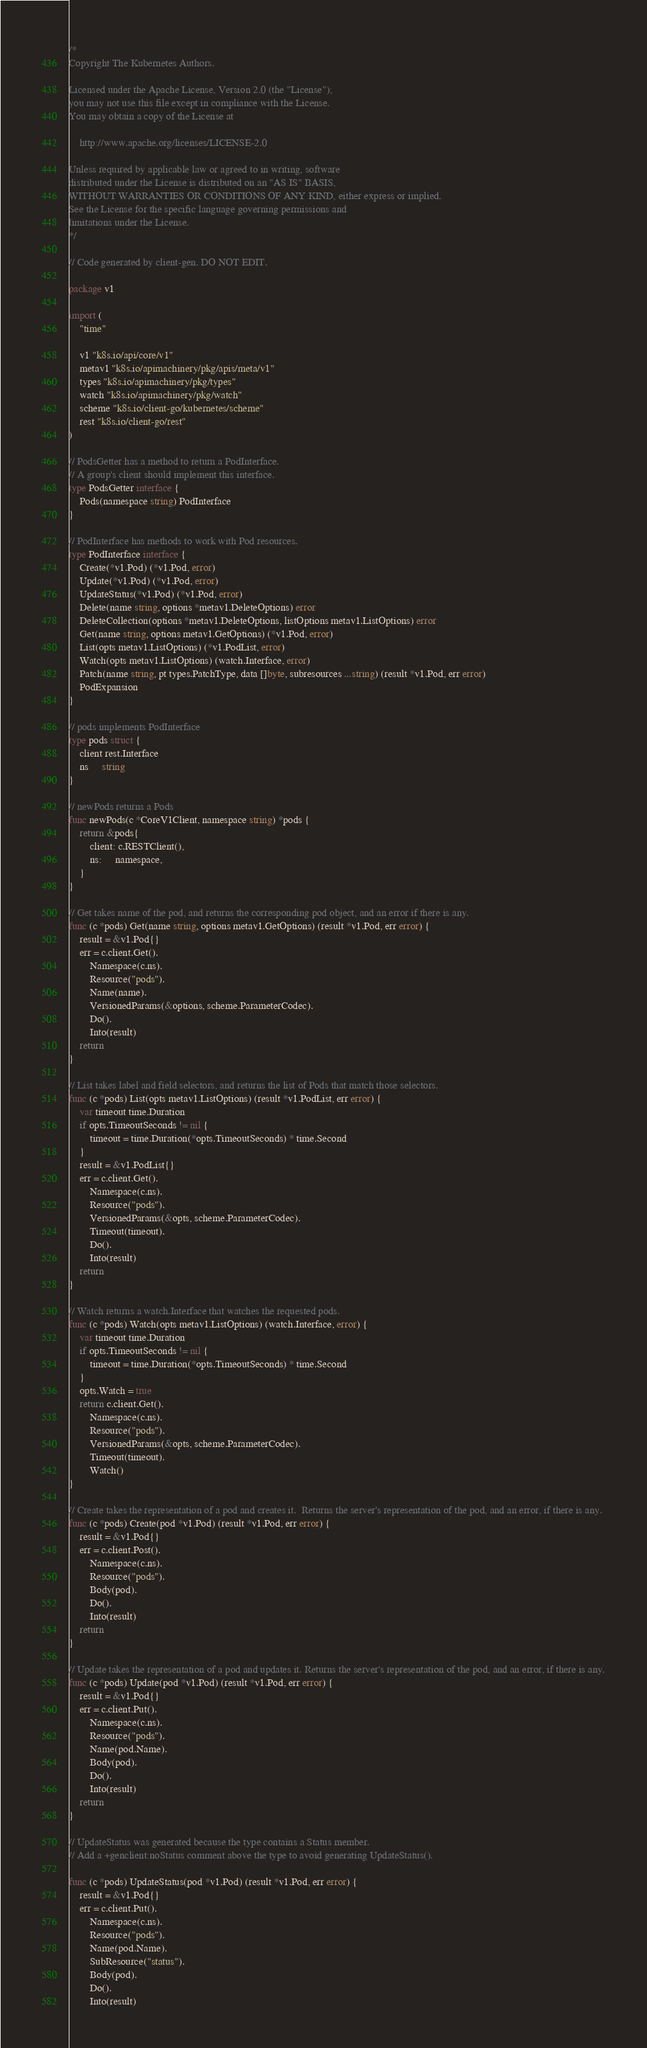<code> <loc_0><loc_0><loc_500><loc_500><_Go_>/*
Copyright The Kubernetes Authors.

Licensed under the Apache License, Version 2.0 (the "License");
you may not use this file except in compliance with the License.
You may obtain a copy of the License at

    http://www.apache.org/licenses/LICENSE-2.0

Unless required by applicable law or agreed to in writing, software
distributed under the License is distributed on an "AS IS" BASIS,
WITHOUT WARRANTIES OR CONDITIONS OF ANY KIND, either express or implied.
See the License for the specific language governing permissions and
limitations under the License.
*/

// Code generated by client-gen. DO NOT EDIT.

package v1

import (
	"time"

	v1 "k8s.io/api/core/v1"
	metav1 "k8s.io/apimachinery/pkg/apis/meta/v1"
	types "k8s.io/apimachinery/pkg/types"
	watch "k8s.io/apimachinery/pkg/watch"
	scheme "k8s.io/client-go/kubernetes/scheme"
	rest "k8s.io/client-go/rest"
)

// PodsGetter has a method to return a PodInterface.
// A group's client should implement this interface.
type PodsGetter interface {
	Pods(namespace string) PodInterface
}

// PodInterface has methods to work with Pod resources.
type PodInterface interface {
	Create(*v1.Pod) (*v1.Pod, error)
	Update(*v1.Pod) (*v1.Pod, error)
	UpdateStatus(*v1.Pod) (*v1.Pod, error)
	Delete(name string, options *metav1.DeleteOptions) error
	DeleteCollection(options *metav1.DeleteOptions, listOptions metav1.ListOptions) error
	Get(name string, options metav1.GetOptions) (*v1.Pod, error)
	List(opts metav1.ListOptions) (*v1.PodList, error)
	Watch(opts metav1.ListOptions) (watch.Interface, error)
	Patch(name string, pt types.PatchType, data []byte, subresources ...string) (result *v1.Pod, err error)
	PodExpansion
}

// pods implements PodInterface
type pods struct {
	client rest.Interface
	ns     string
}

// newPods returns a Pods
func newPods(c *CoreV1Client, namespace string) *pods {
	return &pods{
		client: c.RESTClient(),
		ns:     namespace,
	}
}

// Get takes name of the pod, and returns the corresponding pod object, and an error if there is any.
func (c *pods) Get(name string, options metav1.GetOptions) (result *v1.Pod, err error) {
	result = &v1.Pod{}
	err = c.client.Get().
		Namespace(c.ns).
		Resource("pods").
		Name(name).
		VersionedParams(&options, scheme.ParameterCodec).
		Do().
		Into(result)
	return
}

// List takes label and field selectors, and returns the list of Pods that match those selectors.
func (c *pods) List(opts metav1.ListOptions) (result *v1.PodList, err error) {
	var timeout time.Duration
	if opts.TimeoutSeconds != nil {
		timeout = time.Duration(*opts.TimeoutSeconds) * time.Second
	}
	result = &v1.PodList{}
	err = c.client.Get().
		Namespace(c.ns).
		Resource("pods").
		VersionedParams(&opts, scheme.ParameterCodec).
		Timeout(timeout).
		Do().
		Into(result)
	return
}

// Watch returns a watch.Interface that watches the requested pods.
func (c *pods) Watch(opts metav1.ListOptions) (watch.Interface, error) {
	var timeout time.Duration
	if opts.TimeoutSeconds != nil {
		timeout = time.Duration(*opts.TimeoutSeconds) * time.Second
	}
	opts.Watch = true
	return c.client.Get().
		Namespace(c.ns).
		Resource("pods").
		VersionedParams(&opts, scheme.ParameterCodec).
		Timeout(timeout).
		Watch()
}

// Create takes the representation of a pod and creates it.  Returns the server's representation of the pod, and an error, if there is any.
func (c *pods) Create(pod *v1.Pod) (result *v1.Pod, err error) {
	result = &v1.Pod{}
	err = c.client.Post().
		Namespace(c.ns).
		Resource("pods").
		Body(pod).
		Do().
		Into(result)
	return
}

// Update takes the representation of a pod and updates it. Returns the server's representation of the pod, and an error, if there is any.
func (c *pods) Update(pod *v1.Pod) (result *v1.Pod, err error) {
	result = &v1.Pod{}
	err = c.client.Put().
		Namespace(c.ns).
		Resource("pods").
		Name(pod.Name).
		Body(pod).
		Do().
		Into(result)
	return
}

// UpdateStatus was generated because the type contains a Status member.
// Add a +genclient:noStatus comment above the type to avoid generating UpdateStatus().

func (c *pods) UpdateStatus(pod *v1.Pod) (result *v1.Pod, err error) {
	result = &v1.Pod{}
	err = c.client.Put().
		Namespace(c.ns).
		Resource("pods").
		Name(pod.Name).
		SubResource("status").
		Body(pod).
		Do().
		Into(result)</code> 